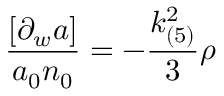<formula> <loc_0><loc_0><loc_500><loc_500>\frac { [ \partial _ { w } a ] } { a _ { 0 } n _ { 0 } } = - \frac { k _ { ( 5 ) } ^ { 2 } } { 3 } \rho</formula> 